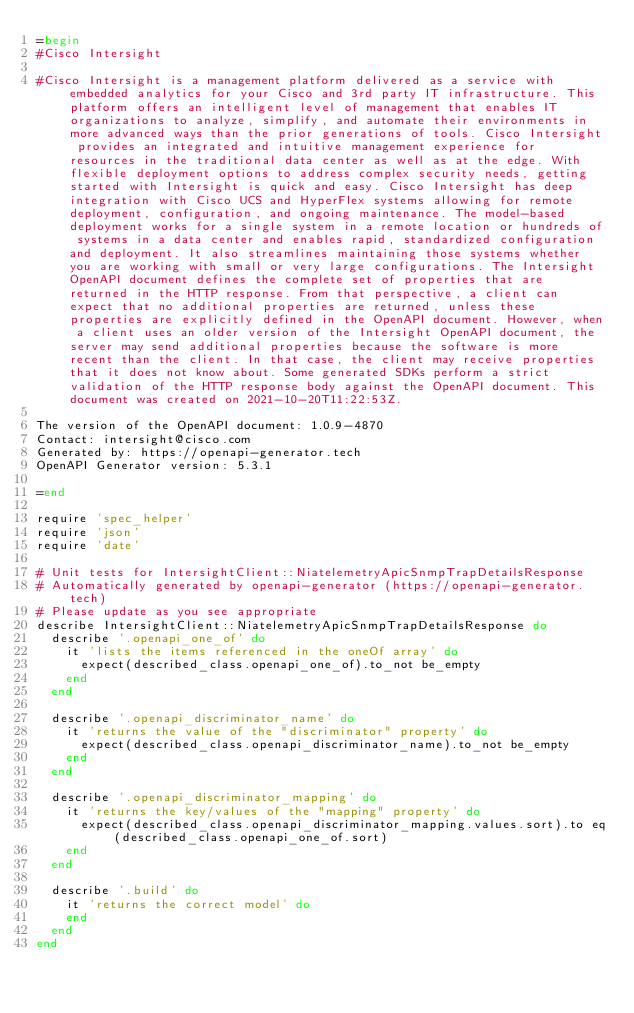Convert code to text. <code><loc_0><loc_0><loc_500><loc_500><_Ruby_>=begin
#Cisco Intersight

#Cisco Intersight is a management platform delivered as a service with embedded analytics for your Cisco and 3rd party IT infrastructure. This platform offers an intelligent level of management that enables IT organizations to analyze, simplify, and automate their environments in more advanced ways than the prior generations of tools. Cisco Intersight provides an integrated and intuitive management experience for resources in the traditional data center as well as at the edge. With flexible deployment options to address complex security needs, getting started with Intersight is quick and easy. Cisco Intersight has deep integration with Cisco UCS and HyperFlex systems allowing for remote deployment, configuration, and ongoing maintenance. The model-based deployment works for a single system in a remote location or hundreds of systems in a data center and enables rapid, standardized configuration and deployment. It also streamlines maintaining those systems whether you are working with small or very large configurations. The Intersight OpenAPI document defines the complete set of properties that are returned in the HTTP response. From that perspective, a client can expect that no additional properties are returned, unless these properties are explicitly defined in the OpenAPI document. However, when a client uses an older version of the Intersight OpenAPI document, the server may send additional properties because the software is more recent than the client. In that case, the client may receive properties that it does not know about. Some generated SDKs perform a strict validation of the HTTP response body against the OpenAPI document. This document was created on 2021-10-20T11:22:53Z.

The version of the OpenAPI document: 1.0.9-4870
Contact: intersight@cisco.com
Generated by: https://openapi-generator.tech
OpenAPI Generator version: 5.3.1

=end

require 'spec_helper'
require 'json'
require 'date'

# Unit tests for IntersightClient::NiatelemetryApicSnmpTrapDetailsResponse
# Automatically generated by openapi-generator (https://openapi-generator.tech)
# Please update as you see appropriate
describe IntersightClient::NiatelemetryApicSnmpTrapDetailsResponse do
  describe '.openapi_one_of' do
    it 'lists the items referenced in the oneOf array' do
      expect(described_class.openapi_one_of).to_not be_empty
    end
  end

  describe '.openapi_discriminator_name' do
    it 'returns the value of the "discriminator" property' do
      expect(described_class.openapi_discriminator_name).to_not be_empty
    end
  end

  describe '.openapi_discriminator_mapping' do
    it 'returns the key/values of the "mapping" property' do
      expect(described_class.openapi_discriminator_mapping.values.sort).to eq(described_class.openapi_one_of.sort)
    end
  end

  describe '.build' do
    it 'returns the correct model' do
    end
  end
end
</code> 